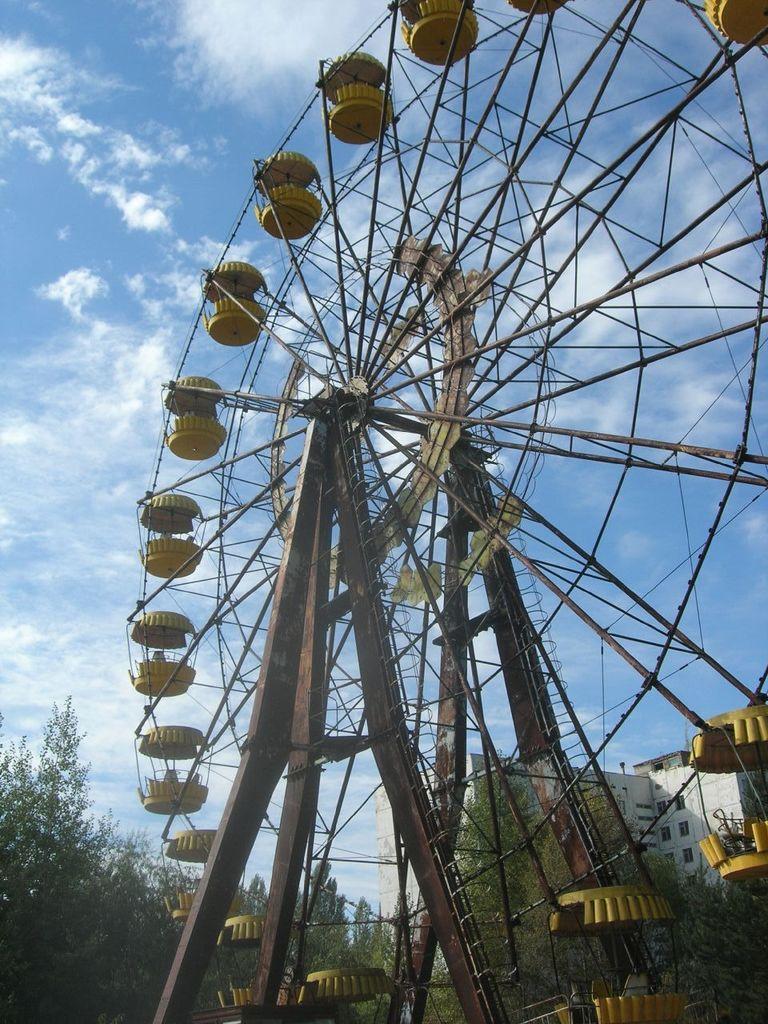Please provide a concise description of this image. We can see giant wheel and rods. In the background we can see building, trees and sky with clouds. 